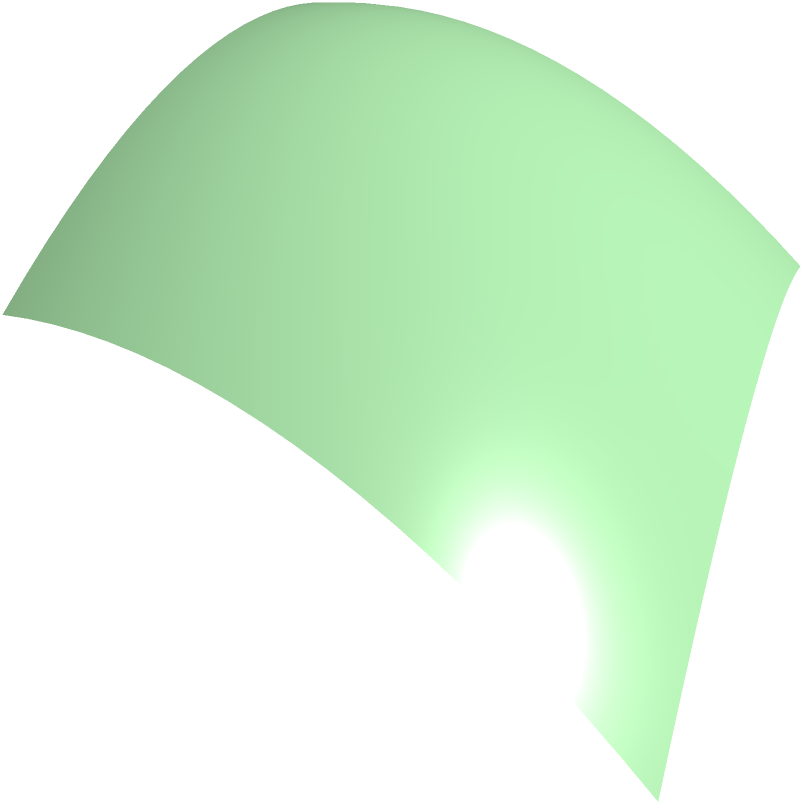A sustainable packaging company is designing a new container with a square base of side length 1 unit and a top surface described by the function $z = 1 - x^2 - y^2$ for $0 \leq x \leq 1$ and $0 \leq y \leq 1$. Calculate the volume of this container using a triple integral. How does this design contribute to reducing material usage compared to a simple cube? To solve this problem, we'll follow these steps:

1) The volume of the container can be calculated using a triple integral:

   $$V = \iiint_V dV = \int_0^1 \int_0^1 \int_0^{1-x^2-y^2} dz dy dx$$

2) First, integrate with respect to z:

   $$V = \int_0^1 \int_0^1 [z]_0^{1-x^2-y^2} dy dx = \int_0^1 \int_0^1 (1-x^2-y^2) dy dx$$

3) Now, integrate with respect to y:

   $$V = \int_0^1 [y - x^2y - \frac{1}{3}y^3]_0^1 dx = \int_0^1 (1 - x^2 - \frac{1}{3}) dx$$

4) Finally, integrate with respect to x:

   $$V = [x - \frac{1}{3}x^3 - \frac{1}{3}x]_0^1 = 1 - \frac{1}{3} - \frac{1}{3} = \frac{1}{3}$$

5) The volume of the container is $\frac{1}{3}$ cubic units.

6) Comparing to a simple cube of side length 1, which would have a volume of 1 cubic unit, this design uses only $\frac{1}{3}$ of the material.

This design contributes to reducing material usage by 66.67% compared to a simple cube, aligning with the ethical business goal of sustainability and resource efficiency.
Answer: $\frac{1}{3}$ cubic units; reduces material usage by 66.67% 